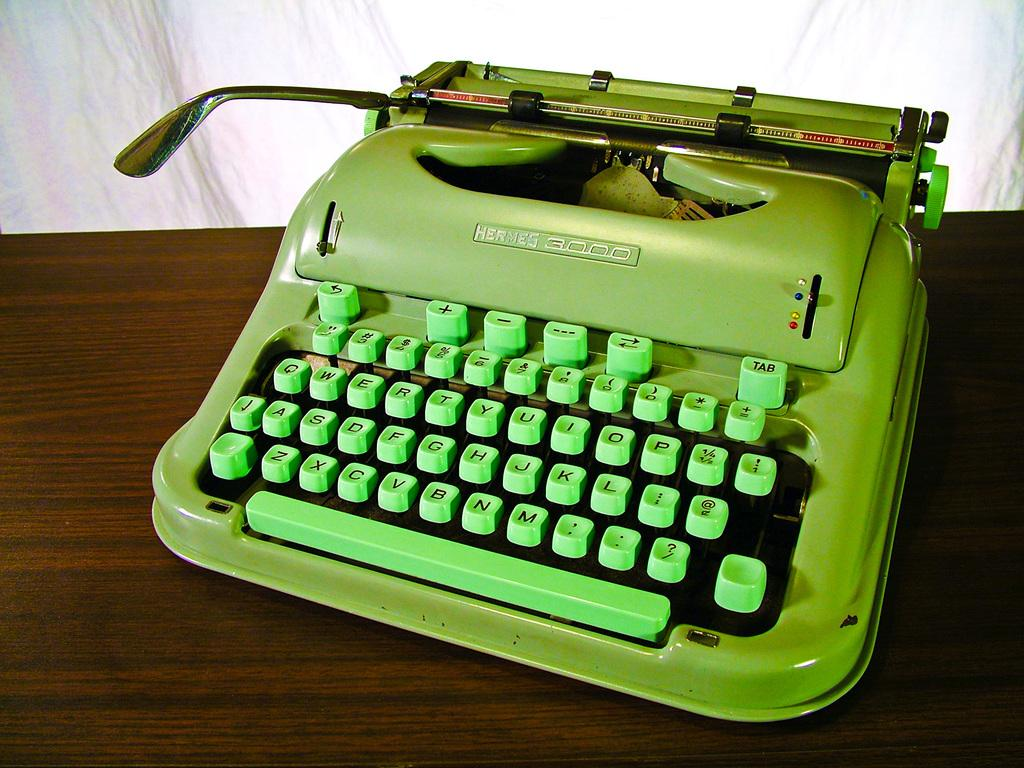<image>
Relay a brief, clear account of the picture shown. The color of the Hermes 3000 is green, with the keys being a brighter green then the type writer itself. 